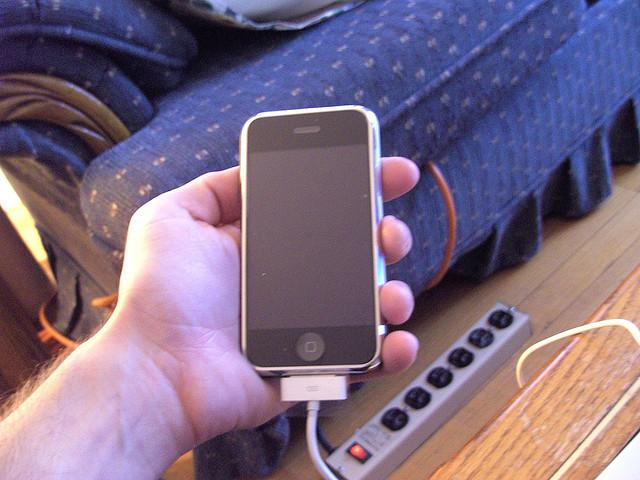What is the item on the floor called? Please explain your reasoning. power strip. One can see the familiar multiple plus that are used to give electricity to an item. 